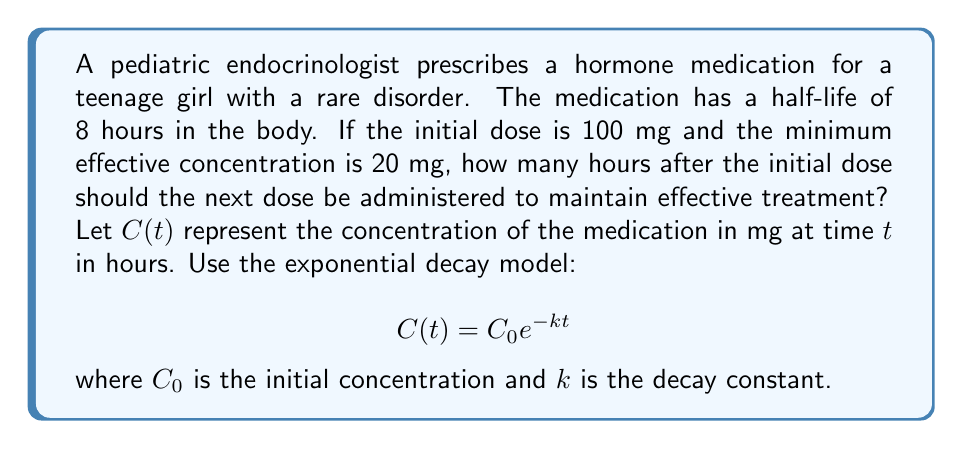Give your solution to this math problem. To solve this problem, we'll follow these steps:

1) First, we need to find the decay constant $k$ using the half-life information:

   At half-life $(t = 8)$, the concentration is half of the initial:
   $$50 = 100 e^{-8k}$$
   
   Solving for $k$:
   $$\frac{1}{2} = e^{-8k}$$
   $$\ln(\frac{1}{2}) = -8k$$
   $$k = \frac{\ln(2)}{8} \approx 0.0866$$

2) Now we can use the exponential decay model to find when the concentration reaches 20 mg:

   $$20 = 100 e^{-0.0866t}$$

3) Solving for $t$:
   $$\frac{1}{5} = e^{-0.0866t}$$
   $$\ln(\frac{1}{5}) = -0.0866t$$
   $$t = \frac{\ln(5)}{0.0866} \approx 18.47$$

Therefore, the next dose should be administered approximately 18.47 hours after the initial dose to maintain the minimum effective concentration.
Answer: The next dose should be administered approximately 18.47 hours after the initial dose. 